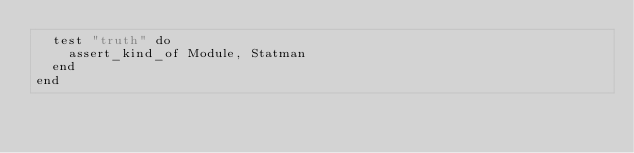<code> <loc_0><loc_0><loc_500><loc_500><_Ruby_>  test "truth" do
    assert_kind_of Module, Statman
  end
end
</code> 